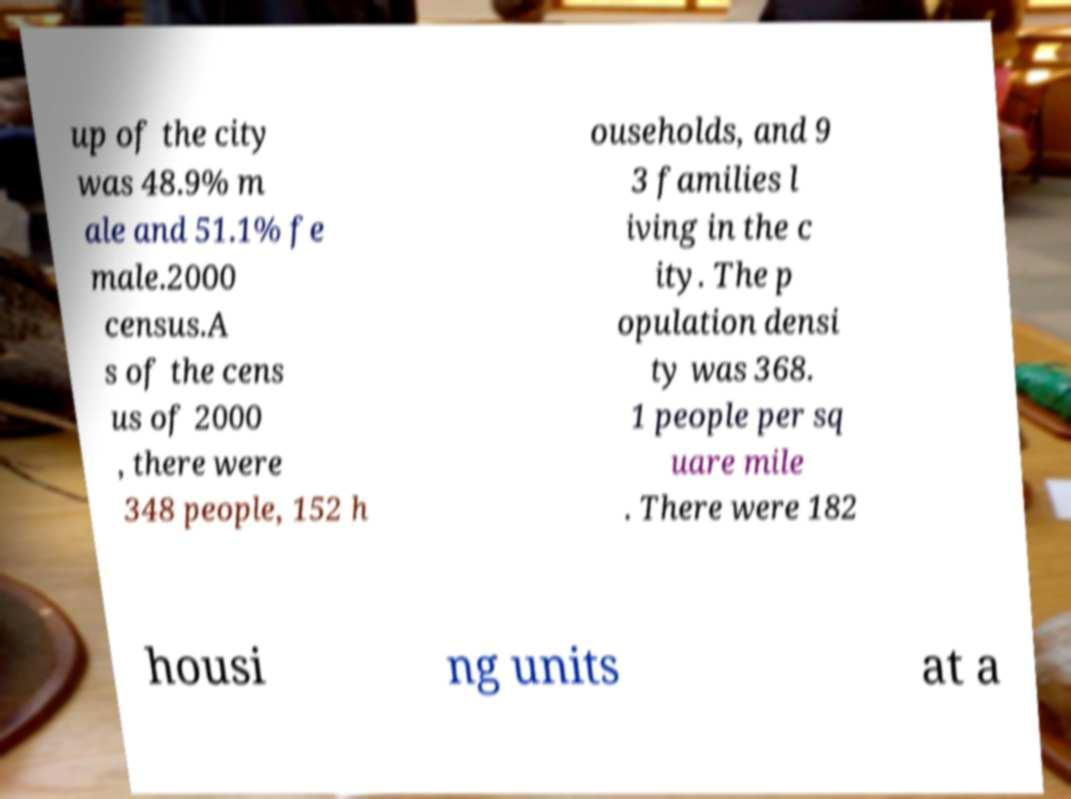What messages or text are displayed in this image? I need them in a readable, typed format. up of the city was 48.9% m ale and 51.1% fe male.2000 census.A s of the cens us of 2000 , there were 348 people, 152 h ouseholds, and 9 3 families l iving in the c ity. The p opulation densi ty was 368. 1 people per sq uare mile . There were 182 housi ng units at a 